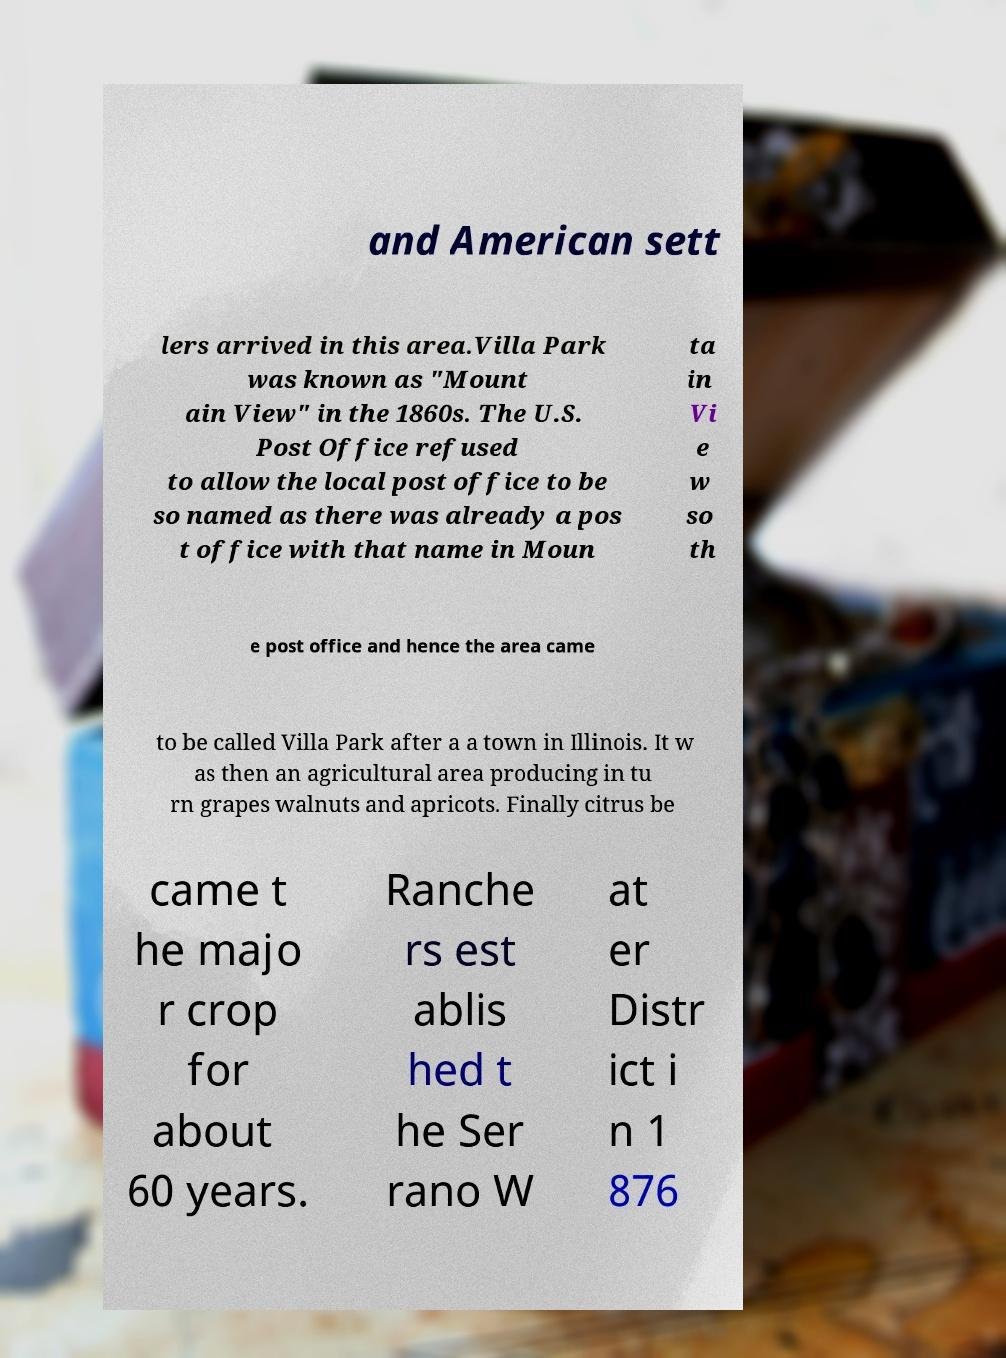Please identify and transcribe the text found in this image. and American sett lers arrived in this area.Villa Park was known as "Mount ain View" in the 1860s. The U.S. Post Office refused to allow the local post office to be so named as there was already a pos t office with that name in Moun ta in Vi e w so th e post office and hence the area came to be called Villa Park after a a town in Illinois. It w as then an agricultural area producing in tu rn grapes walnuts and apricots. Finally citrus be came t he majo r crop for about 60 years. Ranche rs est ablis hed t he Ser rano W at er Distr ict i n 1 876 